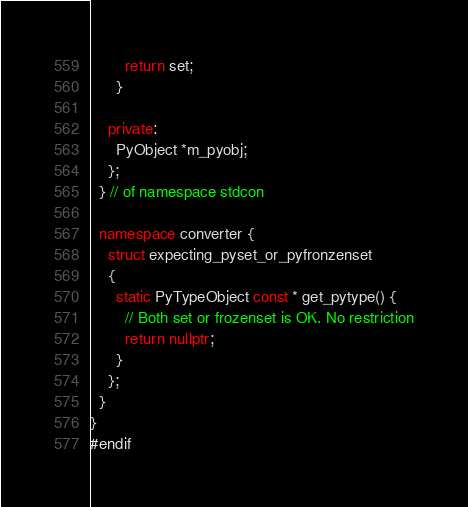<code> <loc_0><loc_0><loc_500><loc_500><_C++_>        return set;
      }

    private:
      PyObject *m_pyobj;
    };
  } // of namespace stdcon

  namespace converter {
    struct expecting_pyset_or_pyfronzenset
    {
      static PyTypeObject const * get_pytype() {
        // Both set or frozenset is OK. No restriction
        return nullptr;
      }
    };
  }
}
#endif
</code> 